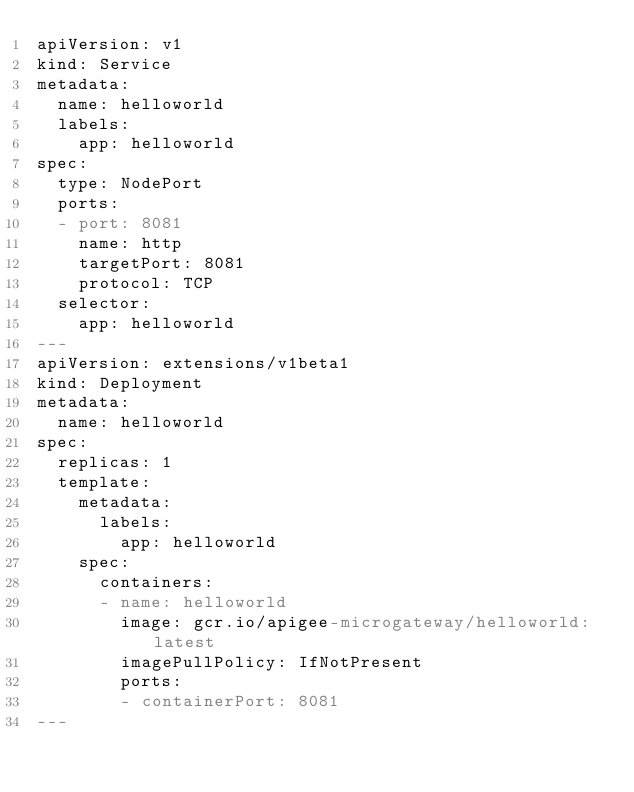Convert code to text. <code><loc_0><loc_0><loc_500><loc_500><_YAML_>apiVersion: v1
kind: Service
metadata:
  name: helloworld
  labels:
    app: helloworld
spec:
  type: NodePort
  ports:
  - port: 8081
    name: http
    targetPort: 8081
    protocol: TCP
  selector:
    app: helloworld
---
apiVersion: extensions/v1beta1
kind: Deployment
metadata:
  name: helloworld
spec:
  replicas: 1
  template:
    metadata:
      labels:
        app: helloworld
    spec:
      containers:
      - name: helloworld
        image: gcr.io/apigee-microgateway/helloworld:latest
        imagePullPolicy: IfNotPresent
        ports:
        - containerPort: 8081
---
</code> 